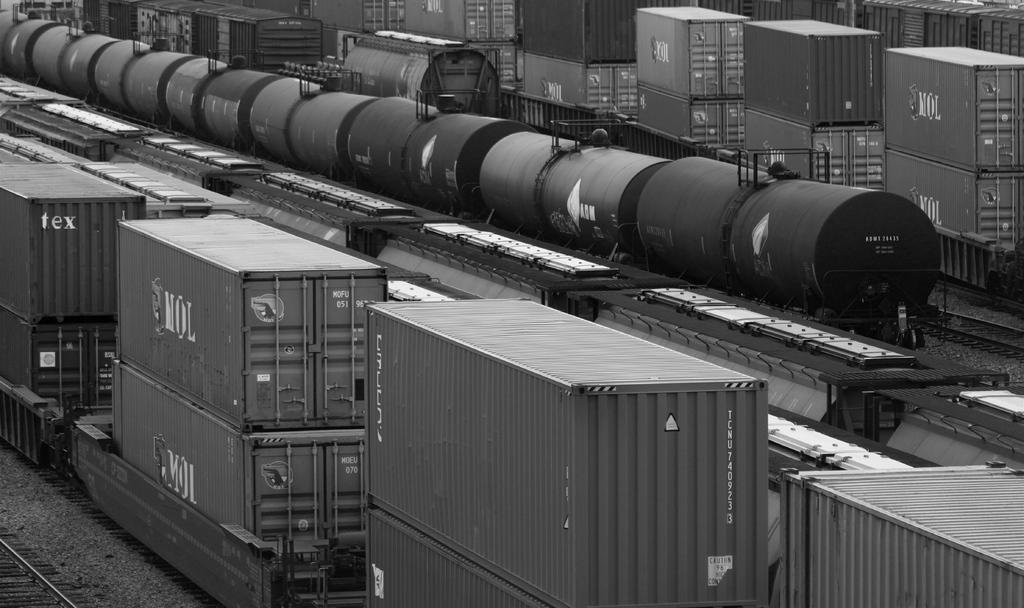In one or two sentences, can you explain what this image depicts? This is a black and white image. In this image we can see containers, train, railway track and other objects. On the left side bottom of the image it looks like a railway track. 